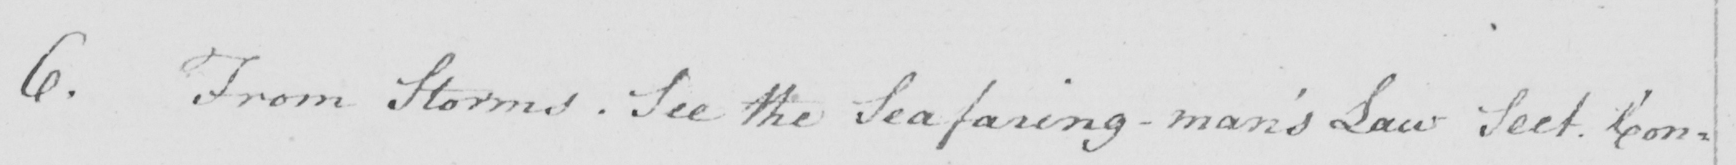What is written in this line of handwriting? 6 . From Storms . See the Seafaring-man ' s Law Sect . Con- 